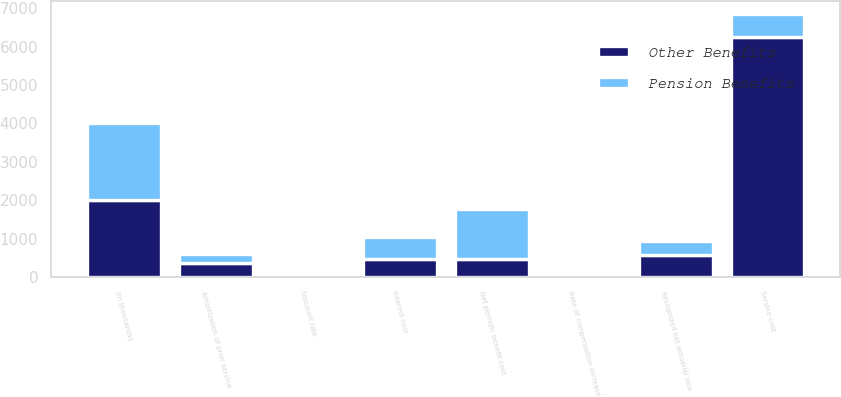Convert chart. <chart><loc_0><loc_0><loc_500><loc_500><stacked_bar_chart><ecel><fcel>(in thousands)<fcel>Service cost<fcel>Interest cost<fcel>Amortization of prior service<fcel>Recognized net actuarial loss<fcel>Net periodic benefit cost<fcel>Discount rate<fcel>Rate of compensation increase<nl><fcel>Other Benefits<fcel>2004<fcel>6248<fcel>461.5<fcel>353<fcel>560<fcel>461.5<fcel>6<fcel>4<nl><fcel>Pension Benefits<fcel>2004<fcel>610<fcel>577<fcel>236<fcel>363<fcel>1314<fcel>5.75<fcel>4<nl></chart> 